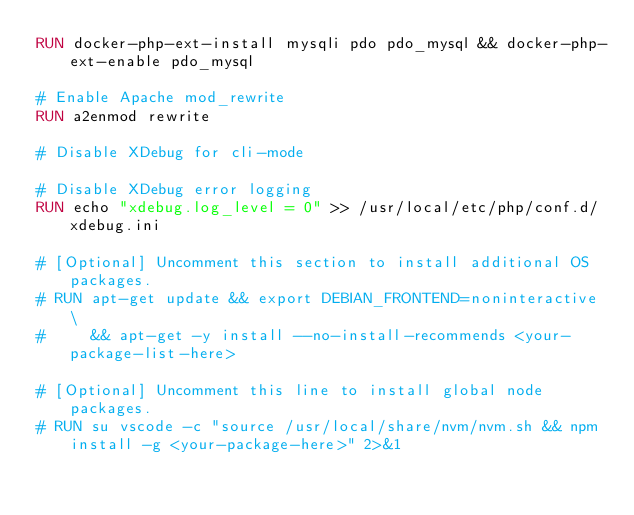<code> <loc_0><loc_0><loc_500><loc_500><_Dockerfile_>RUN docker-php-ext-install mysqli pdo pdo_mysql && docker-php-ext-enable pdo_mysql

# Enable Apache mod_rewrite
RUN a2enmod rewrite

# Disable XDebug for cli-mode

# Disable XDebug error logging
RUN echo "xdebug.log_level = 0" >> /usr/local/etc/php/conf.d/xdebug.ini

# [Optional] Uncomment this section to install additional OS packages.
# RUN apt-get update && export DEBIAN_FRONTEND=noninteractive \
#     && apt-get -y install --no-install-recommends <your-package-list-here>

# [Optional] Uncomment this line to install global node packages.
# RUN su vscode -c "source /usr/local/share/nvm/nvm.sh && npm install -g <your-package-here>" 2>&1
</code> 